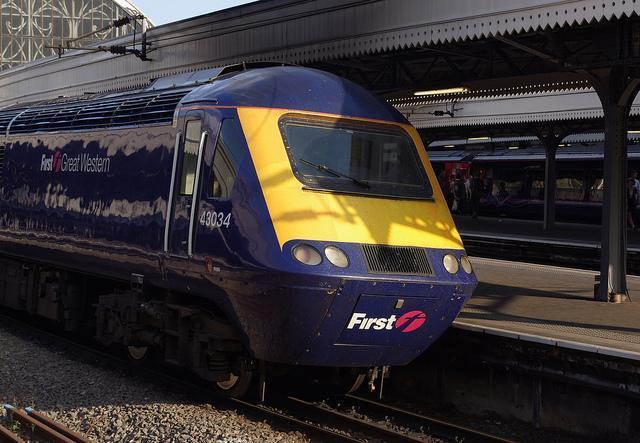How many trains are there?
Give a very brief answer. 1. How many cats are there?
Give a very brief answer. 0. 